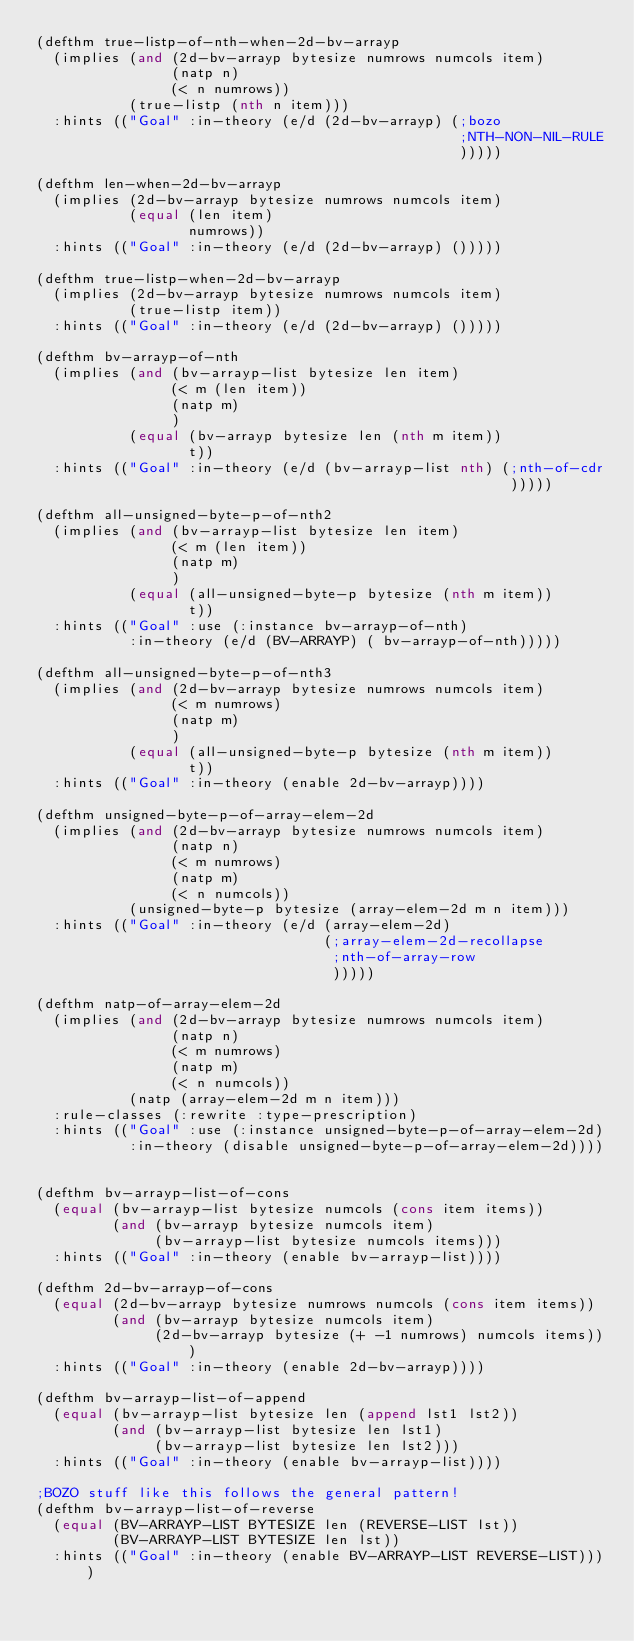Convert code to text. <code><loc_0><loc_0><loc_500><loc_500><_Lisp_>(defthm true-listp-of-nth-when-2d-bv-arrayp
  (implies (and (2d-bv-arrayp bytesize numrows numcols item)
                (natp n)
                (< n numrows))
           (true-listp (nth n item)))
  :hints (("Goal" :in-theory (e/d (2d-bv-arrayp) (;bozo
                                                  ;NTH-NON-NIL-RULE
                                                  )))))

(defthm len-when-2d-bv-arrayp
  (implies (2d-bv-arrayp bytesize numrows numcols item)
           (equal (len item)
                  numrows))
  :hints (("Goal" :in-theory (e/d (2d-bv-arrayp) ()))))

(defthm true-listp-when-2d-bv-arrayp
  (implies (2d-bv-arrayp bytesize numrows numcols item)
           (true-listp item))
  :hints (("Goal" :in-theory (e/d (2d-bv-arrayp) ()))))

(defthm bv-arrayp-of-nth
  (implies (and (bv-arrayp-list bytesize len item)
                (< m (len item))
                (natp m)
                )
           (equal (bv-arrayp bytesize len (nth m item))
                  t))
  :hints (("Goal" :in-theory (e/d (bv-arrayp-list nth) (;nth-of-cdr
                                                        )))))

(defthm all-unsigned-byte-p-of-nth2
  (implies (and (bv-arrayp-list bytesize len item)
                (< m (len item))
                (natp m)
                )
           (equal (all-unsigned-byte-p bytesize (nth m item))
                  t))
  :hints (("Goal" :use (:instance bv-arrayp-of-nth)
           :in-theory (e/d (BV-ARRAYP) ( bv-arrayp-of-nth)))))

(defthm all-unsigned-byte-p-of-nth3
  (implies (and (2d-bv-arrayp bytesize numrows numcols item)
                (< m numrows)
                (natp m)
                )
           (equal (all-unsigned-byte-p bytesize (nth m item))
                  t))
  :hints (("Goal" :in-theory (enable 2d-bv-arrayp))))

(defthm unsigned-byte-p-of-array-elem-2d
  (implies (and (2d-bv-arrayp bytesize numrows numcols item)
                (natp n)
                (< m numrows)
                (natp m)
                (< n numcols))
           (unsigned-byte-p bytesize (array-elem-2d m n item)))
  :hints (("Goal" :in-theory (e/d (array-elem-2d)
                                  (;array-elem-2d-recollapse
                                   ;nth-of-array-row
                                   )))))

(defthm natp-of-array-elem-2d
  (implies (and (2d-bv-arrayp bytesize numrows numcols item)
                (natp n)
                (< m numrows)
                (natp m)
                (< n numcols))
           (natp (array-elem-2d m n item)))
  :rule-classes (:rewrite :type-prescription)
  :hints (("Goal" :use (:instance unsigned-byte-p-of-array-elem-2d)
           :in-theory (disable unsigned-byte-p-of-array-elem-2d))))


(defthm bv-arrayp-list-of-cons
  (equal (bv-arrayp-list bytesize numcols (cons item items))
         (and (bv-arrayp bytesize numcols item)
              (bv-arrayp-list bytesize numcols items)))
  :hints (("Goal" :in-theory (enable bv-arrayp-list))))

(defthm 2d-bv-arrayp-of-cons
  (equal (2d-bv-arrayp bytesize numrows numcols (cons item items))
         (and (bv-arrayp bytesize numcols item)
              (2d-bv-arrayp bytesize (+ -1 numrows) numcols items)))
  :hints (("Goal" :in-theory (enable 2d-bv-arrayp))))

(defthm bv-arrayp-list-of-append
  (equal (bv-arrayp-list bytesize len (append lst1 lst2))
         (and (bv-arrayp-list bytesize len lst1)
              (bv-arrayp-list bytesize len lst2)))
  :hints (("Goal" :in-theory (enable bv-arrayp-list))))

;BOZO stuff like this follows the general pattern!
(defthm bv-arrayp-list-of-reverse
  (equal (BV-ARRAYP-LIST BYTESIZE len (REVERSE-LIST lst))
         (BV-ARRAYP-LIST BYTESIZE len lst))
  :hints (("Goal" :in-theory (enable BV-ARRAYP-LIST REVERSE-LIST))))
</code> 